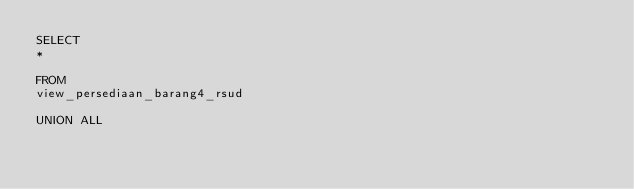Convert code to text. <code><loc_0><loc_0><loc_500><loc_500><_SQL_>SELECT
*

FROM
view_persediaan_barang4_rsud

UNION ALL
</code> 